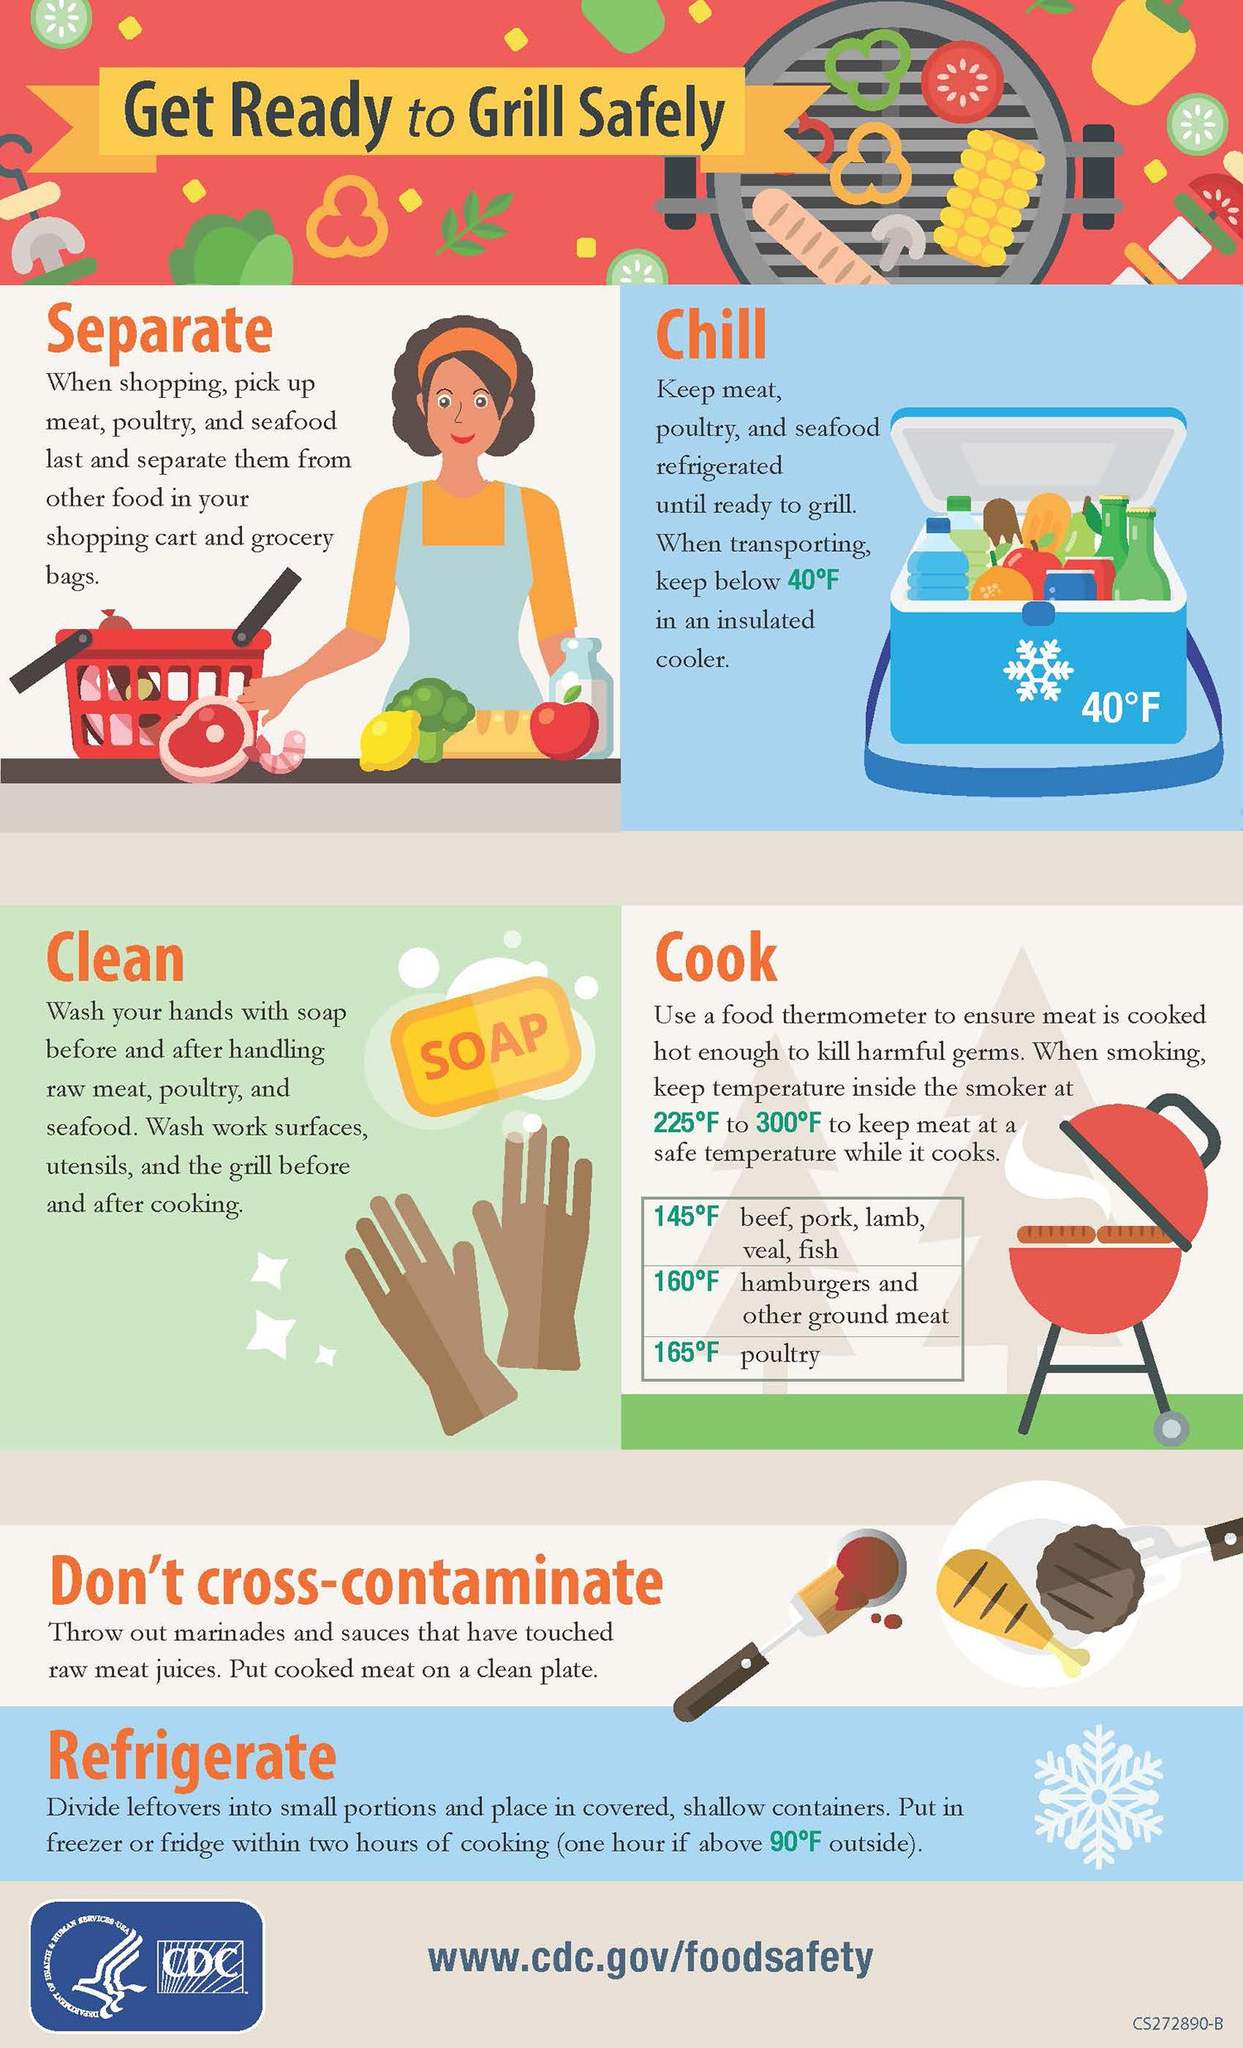Specify some key components in this picture. Six steps must be followed for safe grilling of food. The safe temperatures to cook fish in Fahrenheits are 145, 160, or 165 degrees Fahrenheit. The temperature written on the blue insulated cooler is 40 degrees Fahrenheit. The yellow rectangle near the image of two hands contains the text 'SOAP'. 